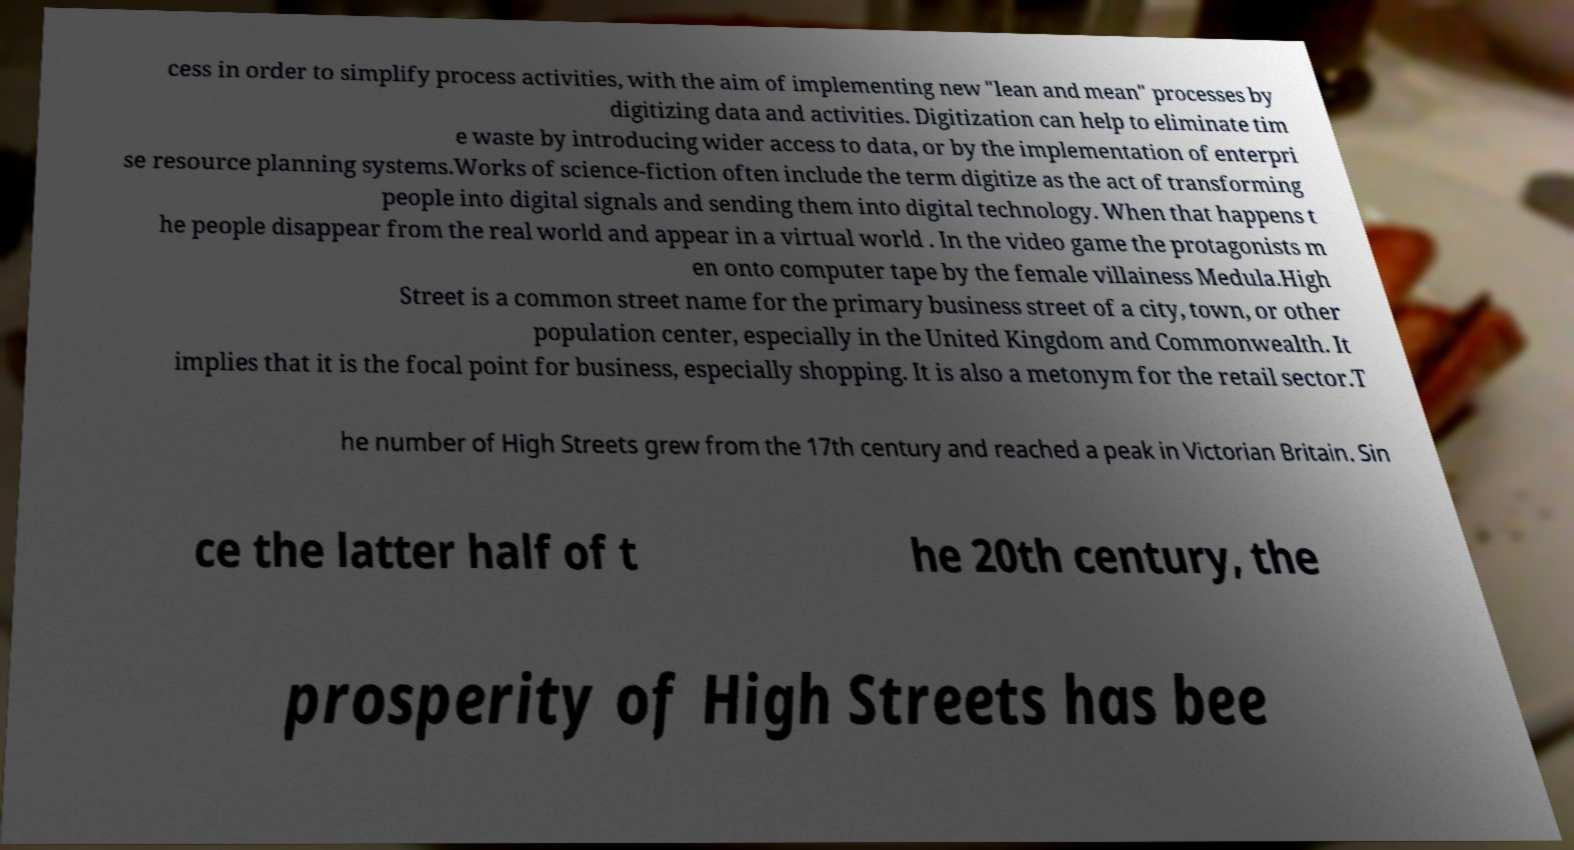For documentation purposes, I need the text within this image transcribed. Could you provide that? cess in order to simplify process activities, with the aim of implementing new "lean and mean" processes by digitizing data and activities. Digitization can help to eliminate tim e waste by introducing wider access to data, or by the implementation of enterpri se resource planning systems.Works of science-fiction often include the term digitize as the act of transforming people into digital signals and sending them into digital technology. When that happens t he people disappear from the real world and appear in a virtual world . In the video game the protagonists m en onto computer tape by the female villainess Medula.High Street is a common street name for the primary business street of a city, town, or other population center, especially in the United Kingdom and Commonwealth. It implies that it is the focal point for business, especially shopping. It is also a metonym for the retail sector.T he number of High Streets grew from the 17th century and reached a peak in Victorian Britain. Sin ce the latter half of t he 20th century, the prosperity of High Streets has bee 